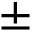Convert formula to latex. <formula><loc_0><loc_0><loc_500><loc_500>\pm</formula> 